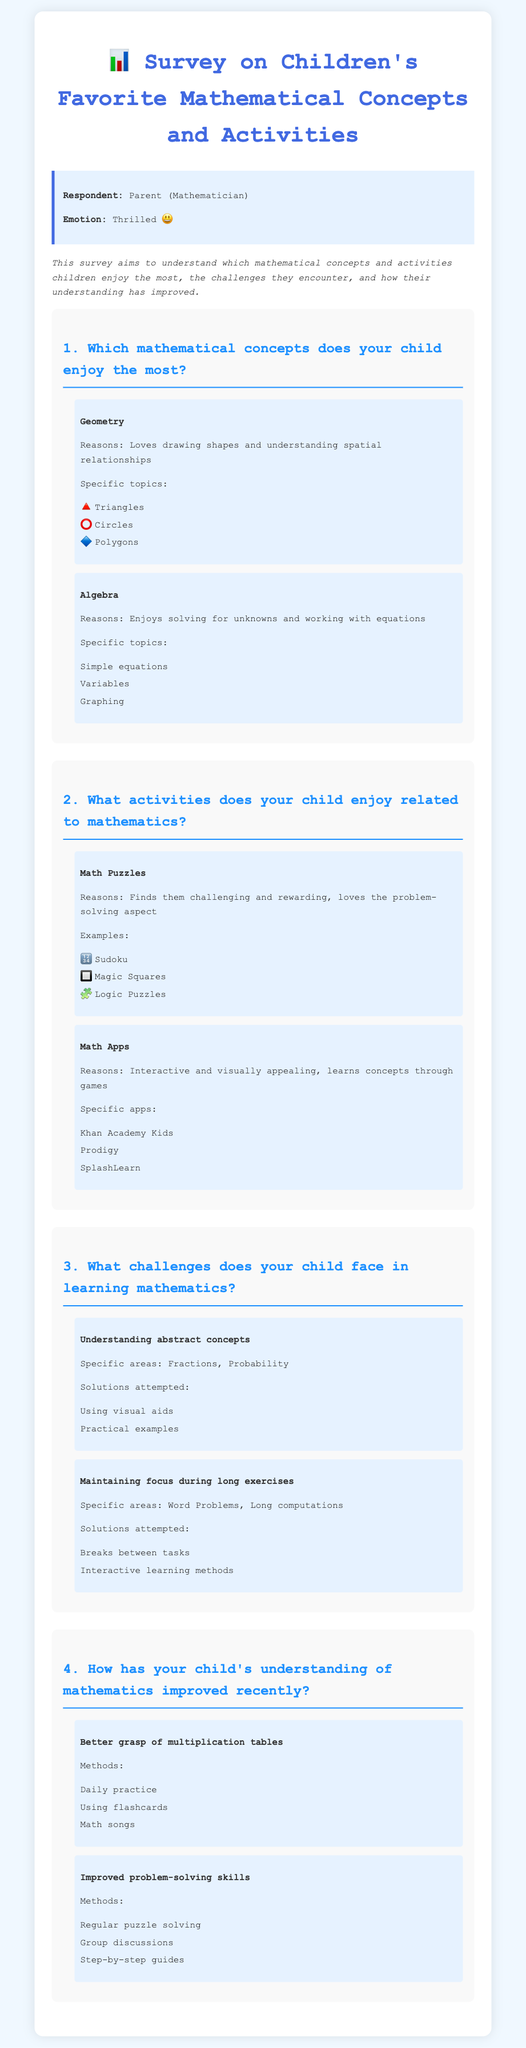What mathematical concept does your child enjoy the most? The concept mentioned for enjoyment is Geometry, as it is the main focus in the response section.
Answer: Geometry What specific topics are included under Algebra? The document lists Simple equations, Variables, and Graphing under Algebra, which are the specific topics enjoyed by the child.
Answer: Simple equations, Variables, Graphing Which math app is mentioned as a favorite? The survey lists Khan Academy Kids, Prodigy, and SplashLearn as the favorite math apps in the responses.
Answer: Khan Academy Kids What challenge does your child face related to focus? The document states that maintaining focus during long exercises is a challenge faced by the child.
Answer: Maintaining focus during long exercises How has your child's understanding of multiplication improved? It is noted that daily practice, using flashcards, and math songs are methods helping improve understanding of multiplication tables.
Answer: Daily practice Which specific areas does your child struggle with regarding abstract concepts? The document mentions Fractions and Probability as specific areas where understanding is challenging.
Answer: Fractions, Probability What methods have been used to enhance problem-solving skills? Regular puzzle solving, group discussions, and step-by-step guides are listed as methods to improve problem-solving skills.
Answer: Regular puzzle solving, group discussions, step-by-step guides What reason is given for enjoying math puzzles? The child finds math puzzles challenging and rewarding, which is stated as reasons for enjoying them.
Answer: Challenging and rewarding Which specific topics in Geometry does your child enjoy the most? The response lists the specific topics enjoyed in Geometry as Triangles, Circles, and Polygons.
Answer: Triangles, Circles, Polygons 